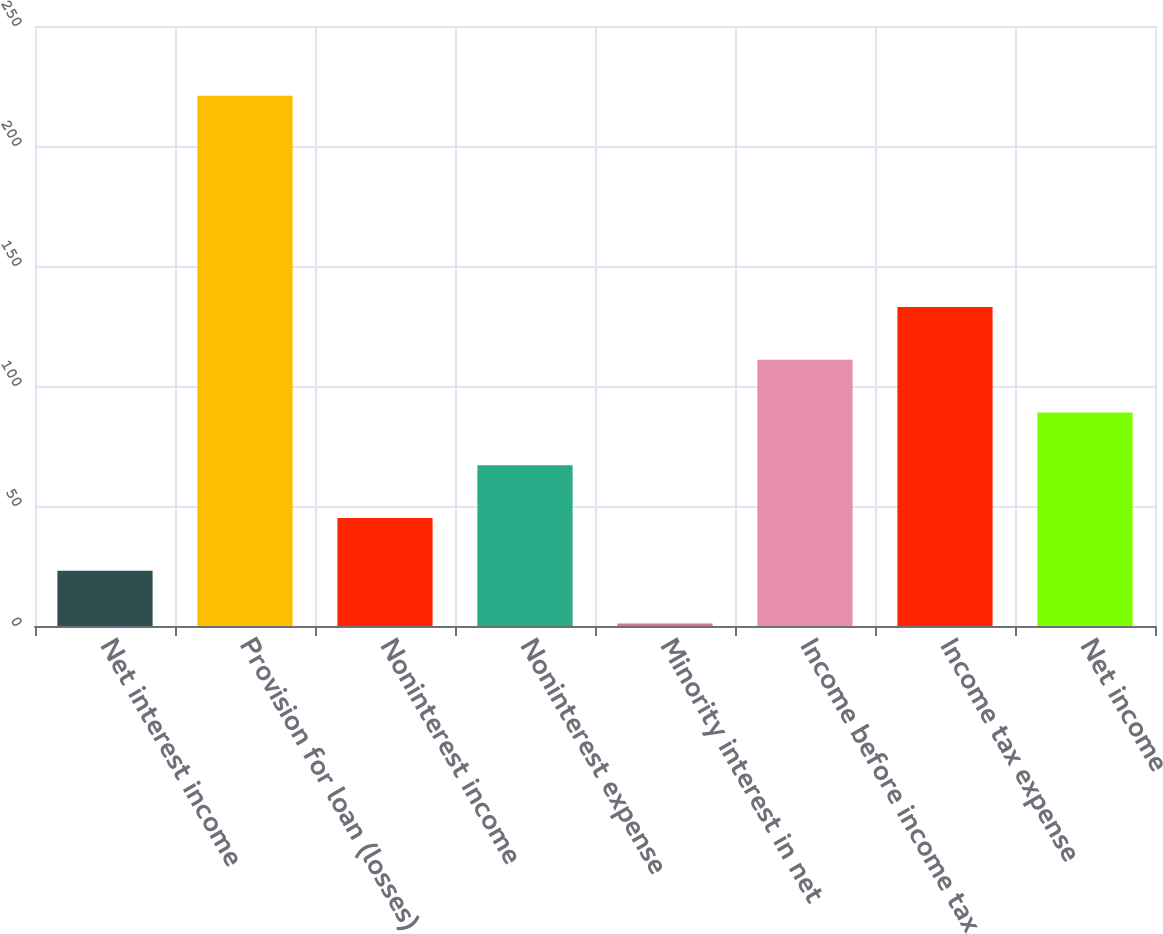Convert chart to OTSL. <chart><loc_0><loc_0><loc_500><loc_500><bar_chart><fcel>Net interest income<fcel>Provision for loan (losses)<fcel>Noninterest income<fcel>Noninterest expense<fcel>Minority interest in net<fcel>Income before income tax<fcel>Income tax expense<fcel>Net income<nl><fcel>22.99<fcel>220.9<fcel>44.98<fcel>66.97<fcel>1<fcel>110.95<fcel>132.94<fcel>88.96<nl></chart> 